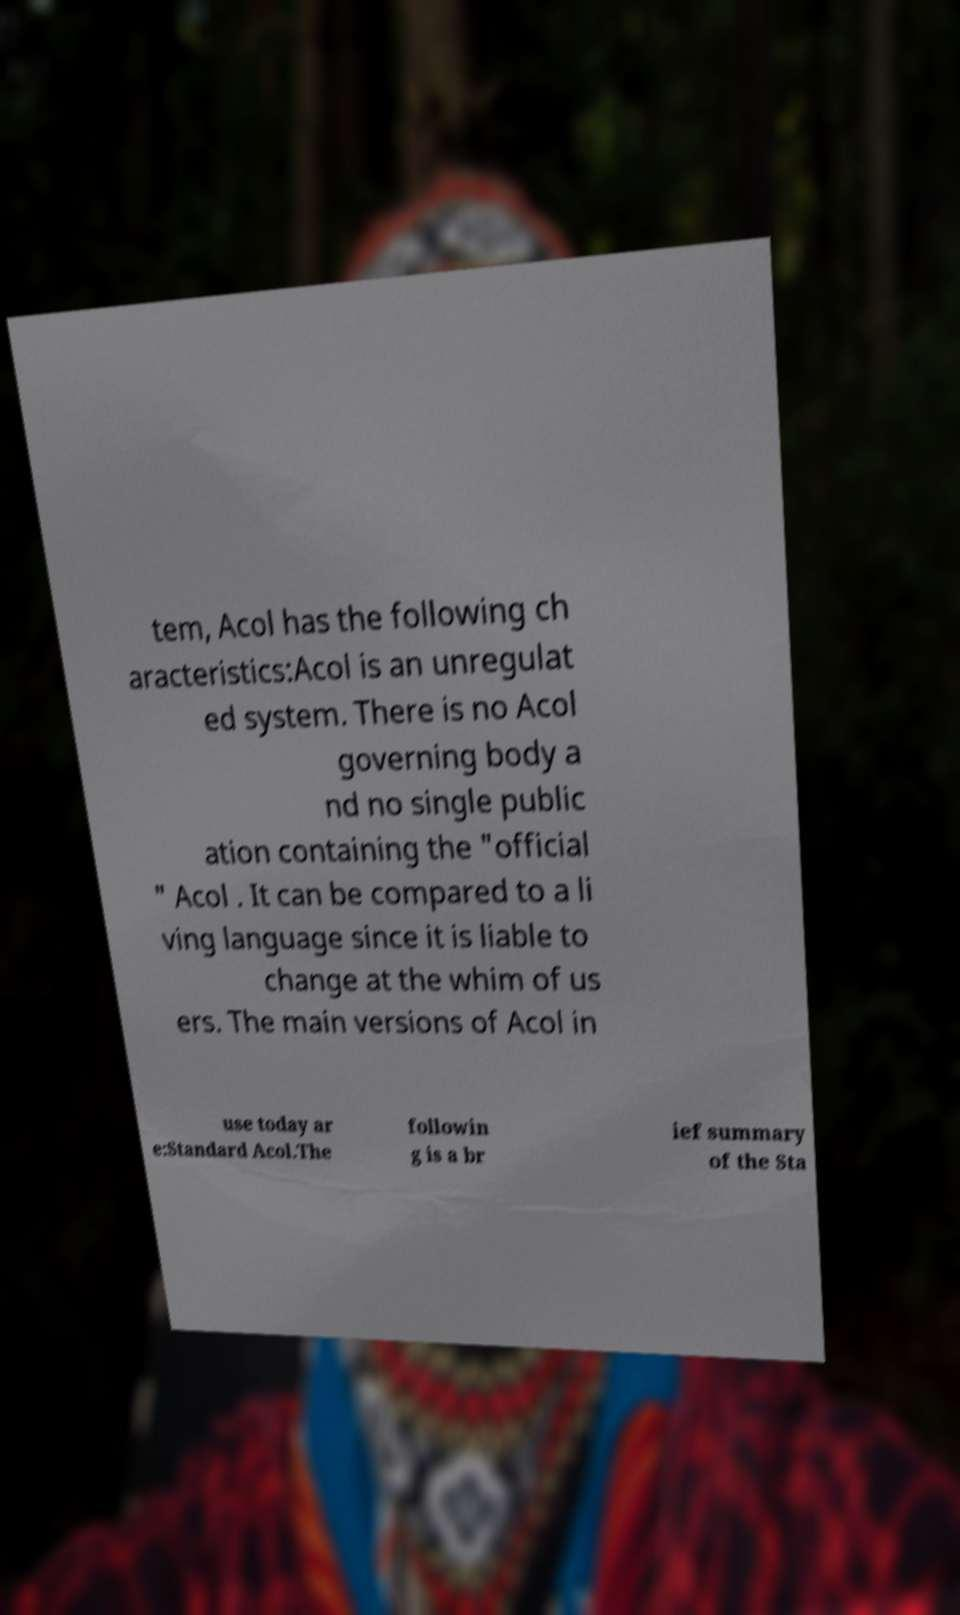Could you assist in decoding the text presented in this image and type it out clearly? tem, Acol has the following ch aracteristics:Acol is an unregulat ed system. There is no Acol governing body a nd no single public ation containing the "official " Acol . It can be compared to a li ving language since it is liable to change at the whim of us ers. The main versions of Acol in use today ar e:Standard Acol.The followin g is a br ief summary of the Sta 